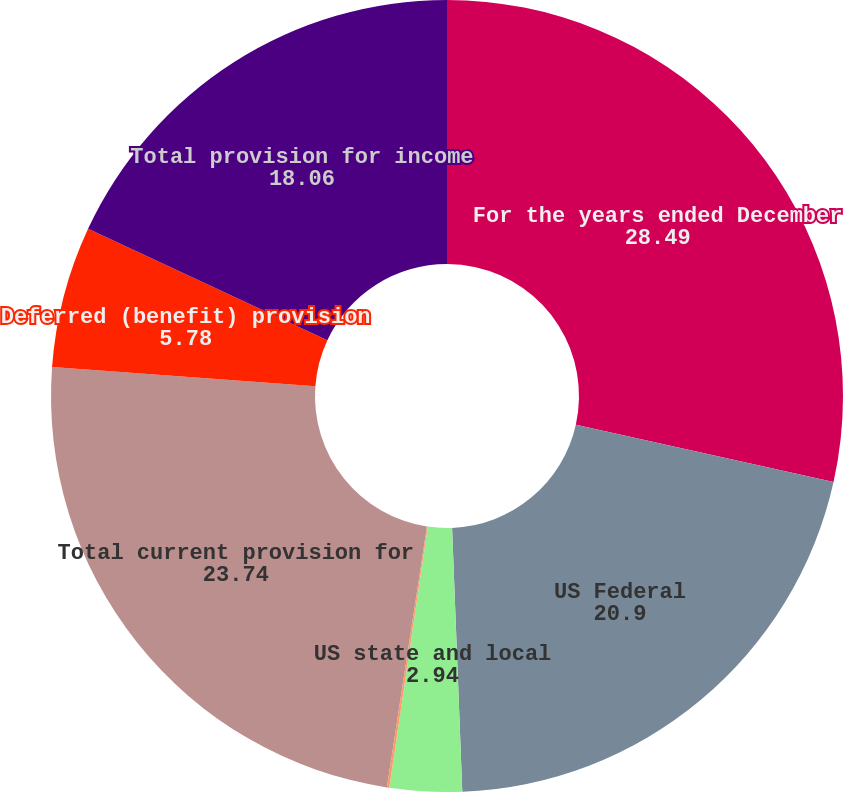Convert chart. <chart><loc_0><loc_0><loc_500><loc_500><pie_chart><fcel>For the years ended December<fcel>US Federal<fcel>US state and local<fcel>Non-US<fcel>Total current provision for<fcel>Deferred (benefit) provision<fcel>Total provision for income<nl><fcel>28.49%<fcel>20.9%<fcel>2.94%<fcel>0.1%<fcel>23.74%<fcel>5.78%<fcel>18.06%<nl></chart> 